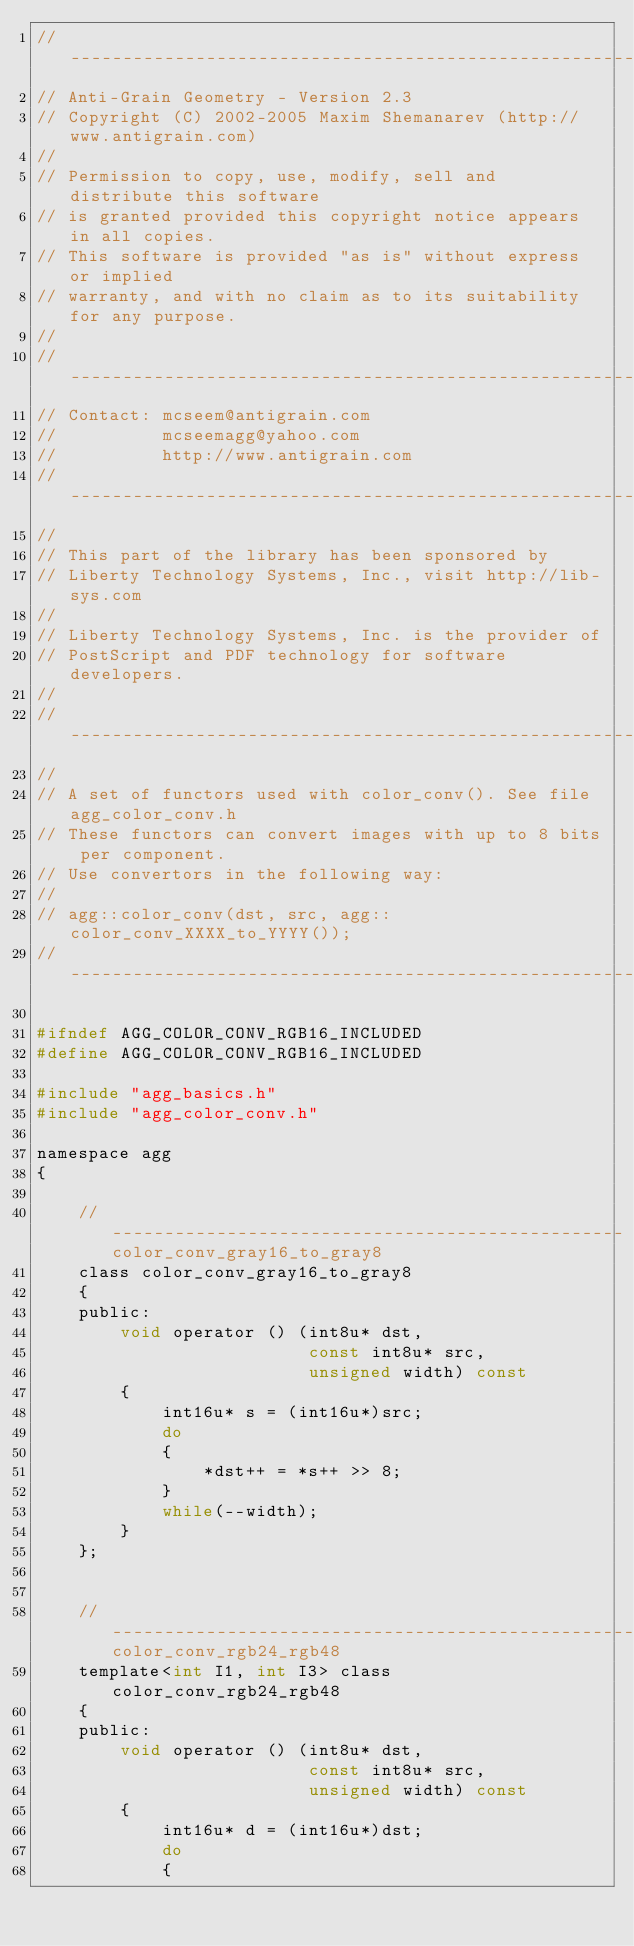Convert code to text. <code><loc_0><loc_0><loc_500><loc_500><_C_>//----------------------------------------------------------------------------
// Anti-Grain Geometry - Version 2.3
// Copyright (C) 2002-2005 Maxim Shemanarev (http://www.antigrain.com)
//
// Permission to copy, use, modify, sell and distribute this software 
// is granted provided this copyright notice appears in all copies. 
// This software is provided "as is" without express or implied
// warranty, and with no claim as to its suitability for any purpose.
//
//----------------------------------------------------------------------------
// Contact: mcseem@antigrain.com
//          mcseemagg@yahoo.com
//          http://www.antigrain.com
//----------------------------------------------------------------------------
//
// This part of the library has been sponsored by 
// Liberty Technology Systems, Inc., visit http://lib-sys.com
//
// Liberty Technology Systems, Inc. is the provider of
// PostScript and PDF technology for software developers.
// 
//----------------------------------------------------------------------------
//
// A set of functors used with color_conv(). See file agg_color_conv.h
// These functors can convert images with up to 8 bits per component.
// Use convertors in the following way:
//
// agg::color_conv(dst, src, agg::color_conv_XXXX_to_YYYY());
//----------------------------------------------------------------------------

#ifndef AGG_COLOR_CONV_RGB16_INCLUDED
#define AGG_COLOR_CONV_RGB16_INCLUDED

#include "agg_basics.h"
#include "agg_color_conv.h"

namespace agg
{

    //-------------------------------------------------color_conv_gray16_to_gray8
    class color_conv_gray16_to_gray8
    {
    public:
        void operator () (int8u* dst, 
                          const int8u* src,
                          unsigned width) const
        {
            int16u* s = (int16u*)src;
            do
            {
                *dst++ = *s++ >> 8;
            }
            while(--width);
        }
    };


    //-----------------------------------------------------color_conv_rgb24_rgb48
    template<int I1, int I3> class color_conv_rgb24_rgb48
    {
    public:
        void operator () (int8u* dst, 
                          const int8u* src,
                          unsigned width) const
        {
            int16u* d = (int16u*)dst;
            do
            {</code> 